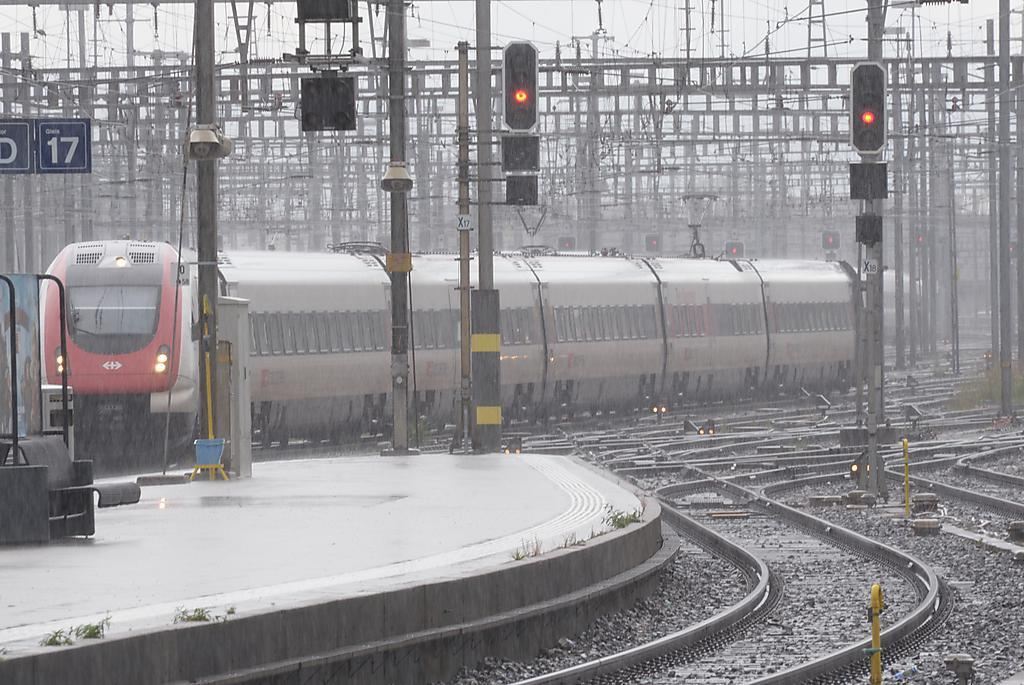What is the main subject in the center of the image? There is a train in the center of the image. What structures can be seen in the image besides the train? There are electric poles, traffic signal lights, and sign boards in the image. What is the train traveling on in the image? There is a track in the image for the train to travel on. Can you describe the eyes of the self in the image? There is no self or person present in the image, so there are no eyes to describe. 